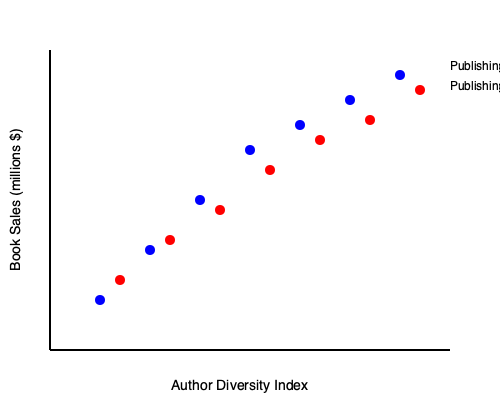Based on the scatter plot showing the relationship between author diversity and book sales for two publishing houses, which publishing house demonstrates a stronger positive correlation between increased author diversity and higher book sales? To determine which publishing house shows a stronger positive correlation between author diversity and book sales, we need to analyze the scatter plot:

1. Observe the general trend for both publishing houses:
   - Publishing House A (blue dots): As we move from left to right (increasing diversity), the points tend to move upward (increasing sales).
   - Publishing House B (red dots): A similar upward trend is observed, but it appears less steep.

2. Compare the steepness of the trends:
   - Publishing House A's trend line would be steeper, indicating a stronger relationship between diversity and sales.
   - Publishing House B's trend line would be less steep, suggesting a weaker relationship.

3. Analyze the consistency of the relationship:
   - Publishing House A's points form a more consistent pattern, with less scatter around the implied trend line.
   - Publishing House B's points show more variability around its implied trend line.

4. Consider the range of the data:
   - Publishing House A covers a wider range of both diversity and sales, providing more evidence for the relationship.
   - Publishing House B has a slightly narrower range, particularly in sales.

5. Evaluate the overall correlation:
   - Publishing House A exhibits a stronger positive correlation due to its steeper trend, more consistent pattern, and wider range of data.
   - Publishing House B shows a positive correlation, but it's not as strong as Publishing House A.

Based on these observations, Publishing House A demonstrates a stronger positive correlation between increased author diversity and higher book sales.
Answer: Publishing House A 